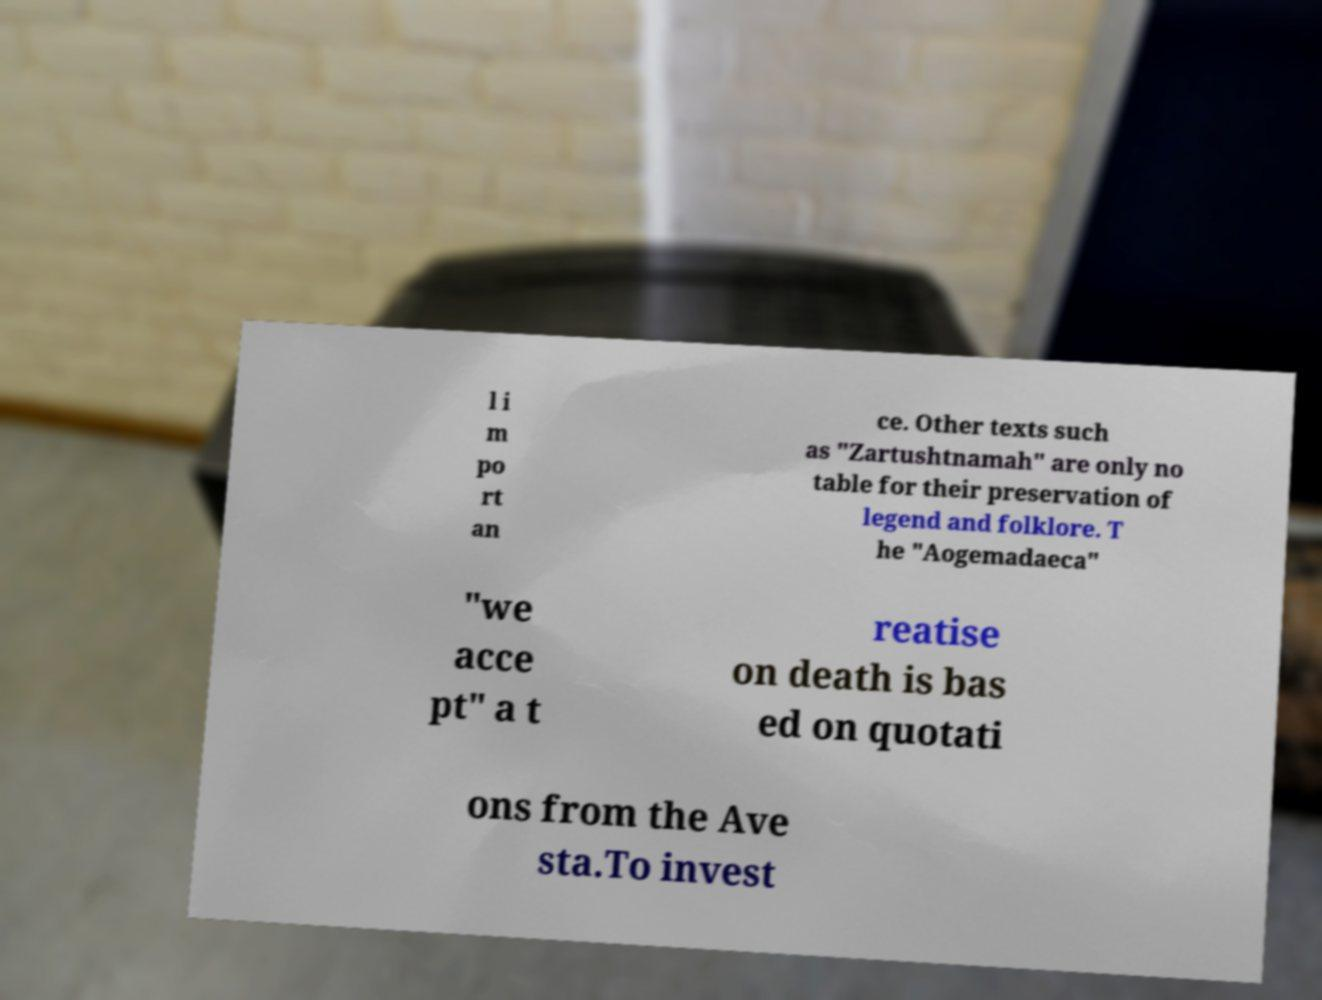Could you extract and type out the text from this image? l i m po rt an ce. Other texts such as "Zartushtnamah" are only no table for their preservation of legend and folklore. T he "Aogemadaeca" "we acce pt" a t reatise on death is bas ed on quotati ons from the Ave sta.To invest 